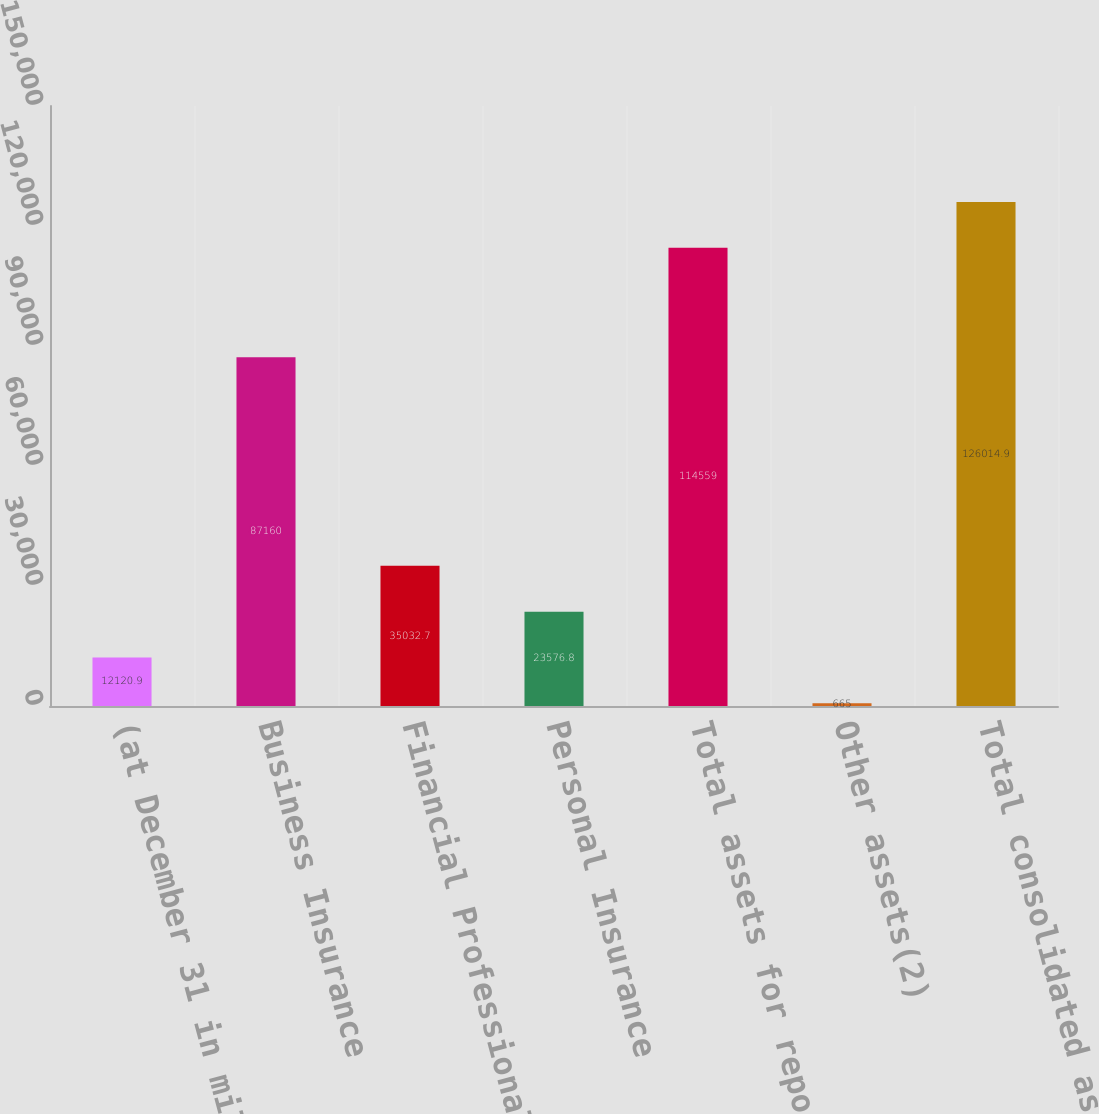<chart> <loc_0><loc_0><loc_500><loc_500><bar_chart><fcel>(at December 31 in millions)<fcel>Business Insurance<fcel>Financial Professional &<fcel>Personal Insurance<fcel>Total assets for reportable<fcel>Other assets(2)<fcel>Total consolidated assets<nl><fcel>12120.9<fcel>87160<fcel>35032.7<fcel>23576.8<fcel>114559<fcel>665<fcel>126015<nl></chart> 